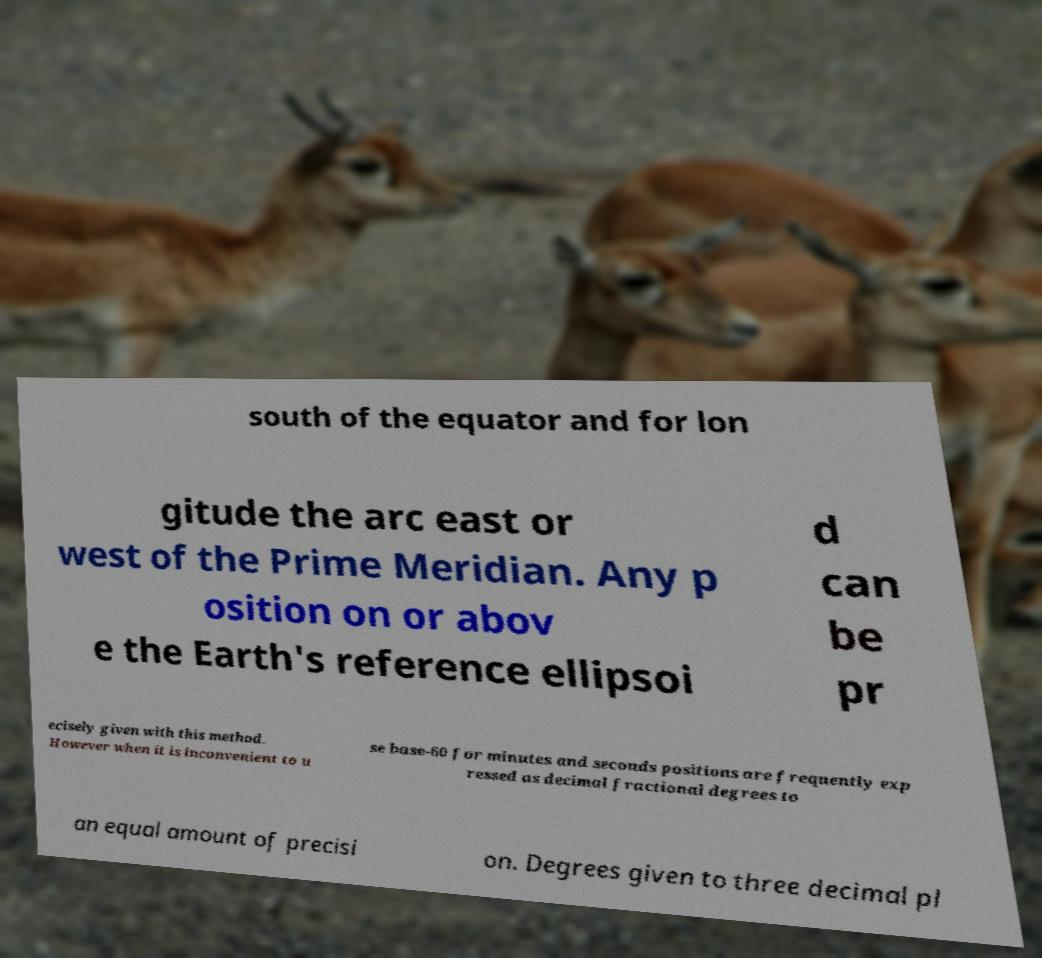Please read and relay the text visible in this image. What does it say? south of the equator and for lon gitude the arc east or west of the Prime Meridian. Any p osition on or abov e the Earth's reference ellipsoi d can be pr ecisely given with this method. However when it is inconvenient to u se base-60 for minutes and seconds positions are frequently exp ressed as decimal fractional degrees to an equal amount of precisi on. Degrees given to three decimal pl 